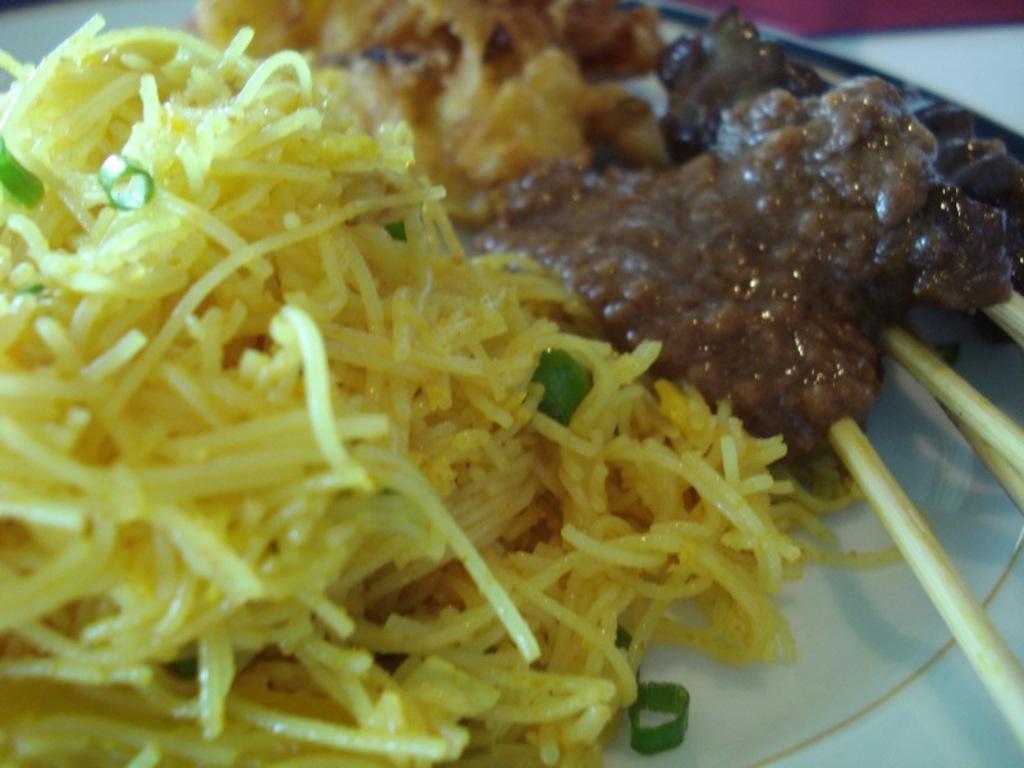In one or two sentences, can you explain what this image depicts? In this image I see food which is on a plate. 